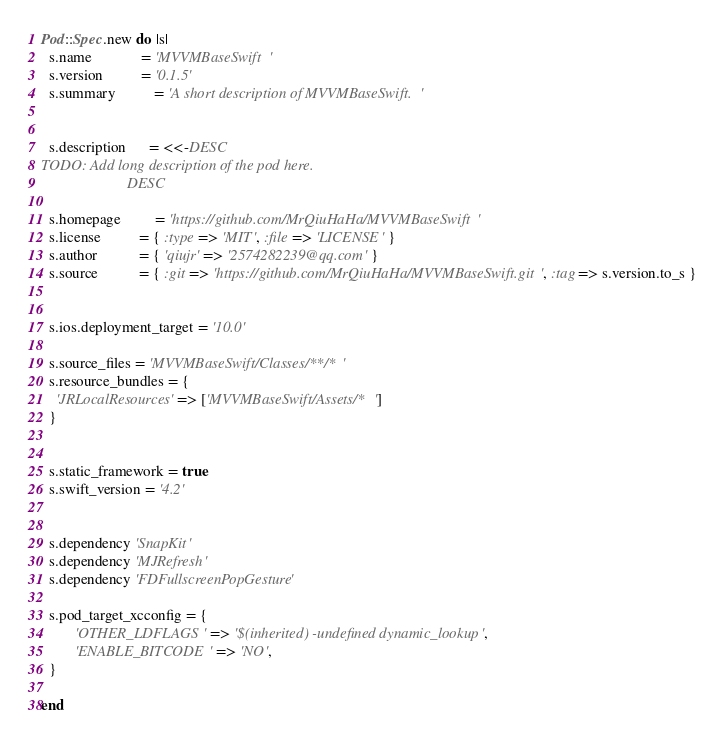<code> <loc_0><loc_0><loc_500><loc_500><_Ruby_>

Pod::Spec.new do |s|
  s.name             = 'MVVMBaseSwift'
  s.version          = '0.1.5'
  s.summary          = 'A short description of MVVMBaseSwift.'


  s.description      = <<-DESC
TODO: Add long description of the pod here.
                       DESC

  s.homepage         = 'https://github.com/MrQiuHaHa/MVVMBaseSwift'
  s.license          = { :type => 'MIT', :file => 'LICENSE' }
  s.author           = { 'qiujr' => '2574282239@qq.com' }
  s.source           = { :git => 'https://github.com/MrQiuHaHa/MVVMBaseSwift.git', :tag => s.version.to_s }
 

  s.ios.deployment_target = '10.0'

  s.source_files = 'MVVMBaseSwift/Classes/**/*'
  s.resource_bundles = {
    'JRLocalResources' => ['MVVMBaseSwift/Assets/*']
  }
   

  s.static_framework = true
  s.swift_version = '4.2'
  
  
  s.dependency 'SnapKit'
  s.dependency 'MJRefresh'
  s.dependency 'FDFullscreenPopGesture'
  
  s.pod_target_xcconfig = {
         'OTHER_LDFLAGS' => '$(inherited) -undefined dynamic_lookup',
         'ENABLE_BITCODE' => 'NO',
  }

end
</code> 